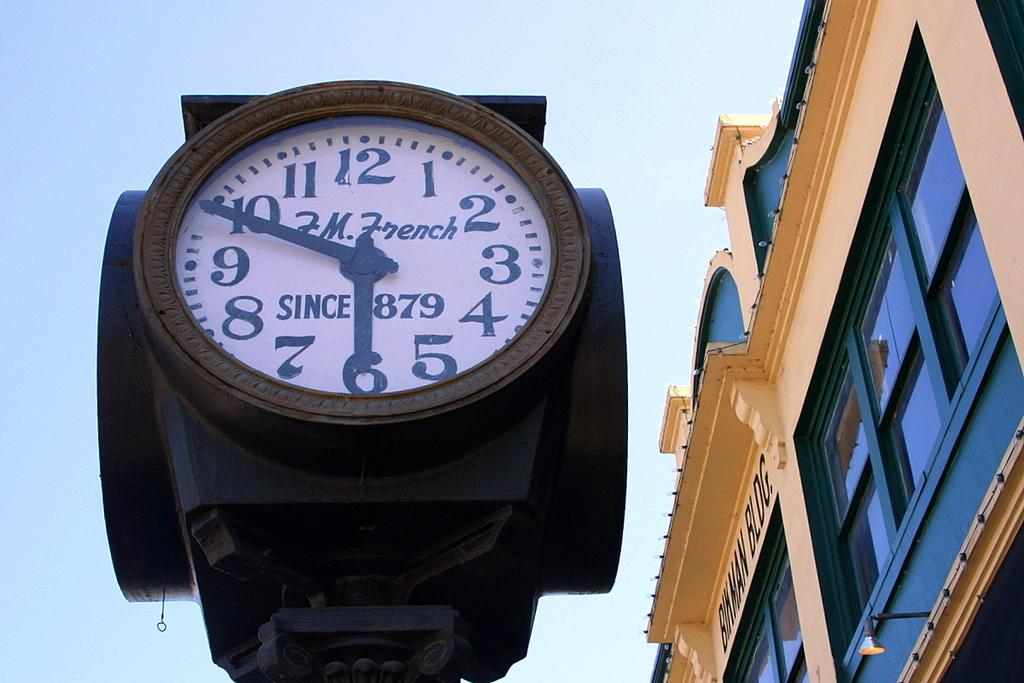<image>
Render a clear and concise summary of the photo. A clock with JM French since 1879 written on it stands outside of a building 